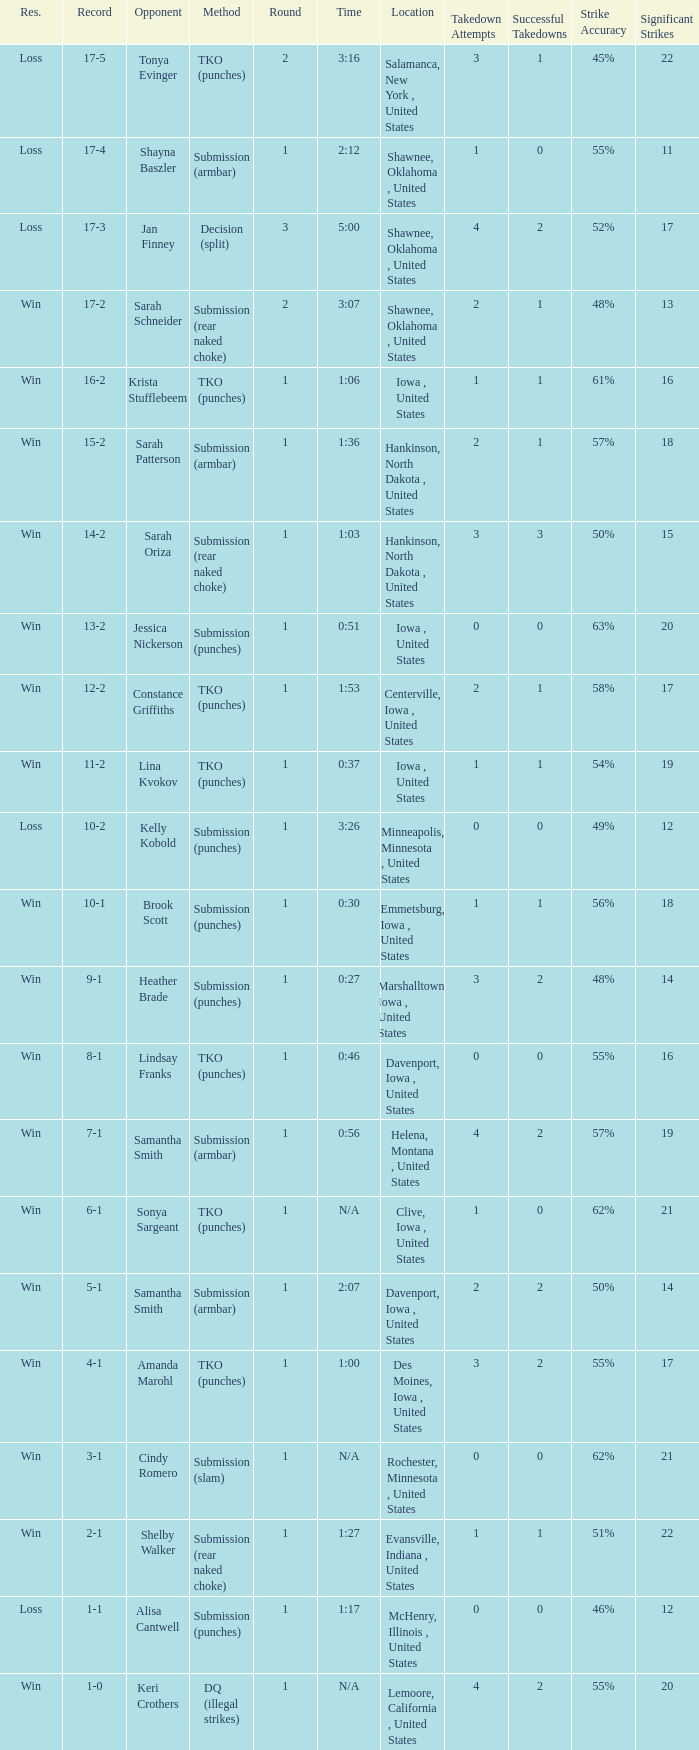What opponent does she fight when she is 10-1? Brook Scott. 